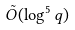<formula> <loc_0><loc_0><loc_500><loc_500>\tilde { O } ( \log ^ { 5 } q )</formula> 